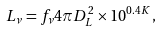Convert formula to latex. <formula><loc_0><loc_0><loc_500><loc_500>L _ { \nu } = f _ { \nu } 4 \pi D _ { L } ^ { 2 } \times 1 0 ^ { 0 . 4 K } ,</formula> 